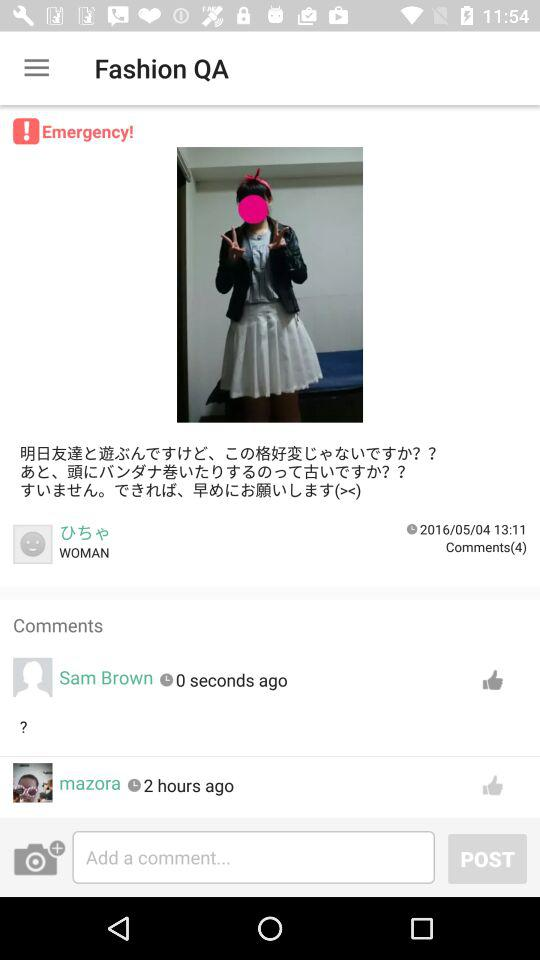When the photo was uploaded?
When the provided information is insufficient, respond with <no answer>. <no answer> 